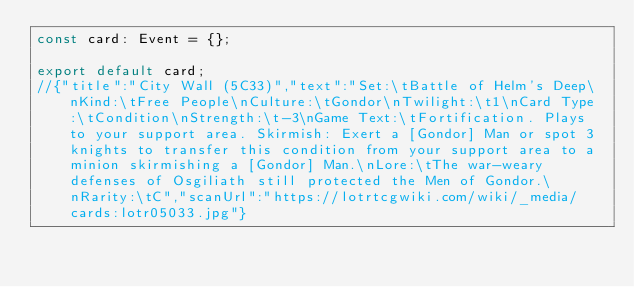<code> <loc_0><loc_0><loc_500><loc_500><_TypeScript_>const card: Event = {};

export default card;
//{"title":"City Wall (5C33)","text":"Set:\tBattle of Helm's Deep\nKind:\tFree People\nCulture:\tGondor\nTwilight:\t1\nCard Type:\tCondition\nStrength:\t-3\nGame Text:\tFortification. Plays to your support area. Skirmish: Exert a [Gondor] Man or spot 3 knights to transfer this condition from your support area to a minion skirmishing a [Gondor] Man.\nLore:\tThe war-weary defenses of Osgiliath still protected the Men of Gondor.\nRarity:\tC","scanUrl":"https://lotrtcgwiki.com/wiki/_media/cards:lotr05033.jpg"}
</code> 